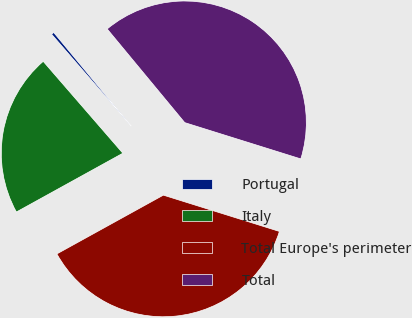<chart> <loc_0><loc_0><loc_500><loc_500><pie_chart><fcel>Portugal<fcel>Italy<fcel>Total Europe's perimeter<fcel>Total<nl><fcel>0.36%<fcel>21.66%<fcel>37.15%<fcel>40.83%<nl></chart> 